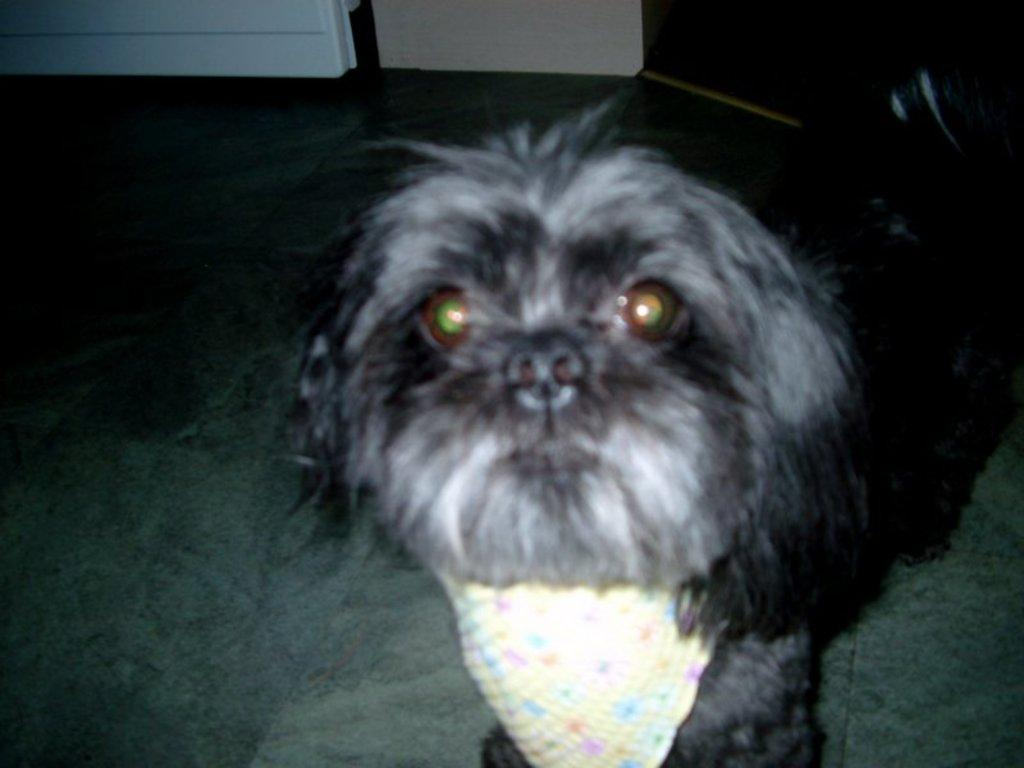What is the main subject in the center of the image? There is a dog in the center of the image. What can be seen in the background of the image? There is a wall in the background of the image. What is visible at the bottom of the image? There is a floor visible at the bottom of the image. What type of fuel is the dog using to power its movements in the image? The dog does not use fuel to power its movements in the image; it is a living creature that moves naturally. 